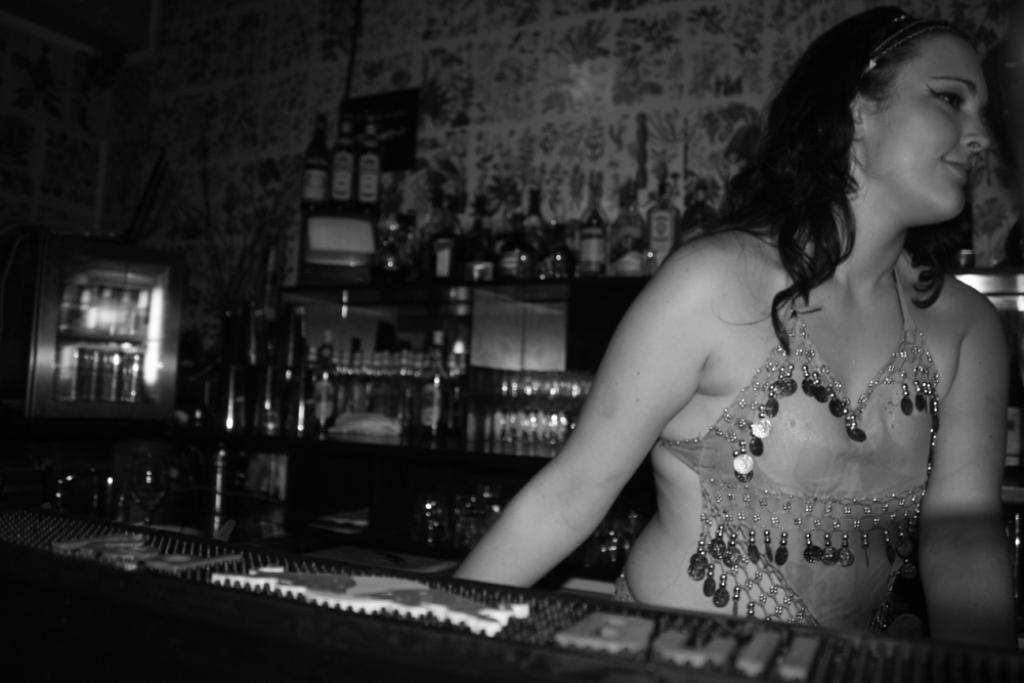Describe this image in one or two sentences. This is a black and white image. In this image we can see a woman standing beside a table. On the backside we can see a group of bottles placed in the racks and a wall. 